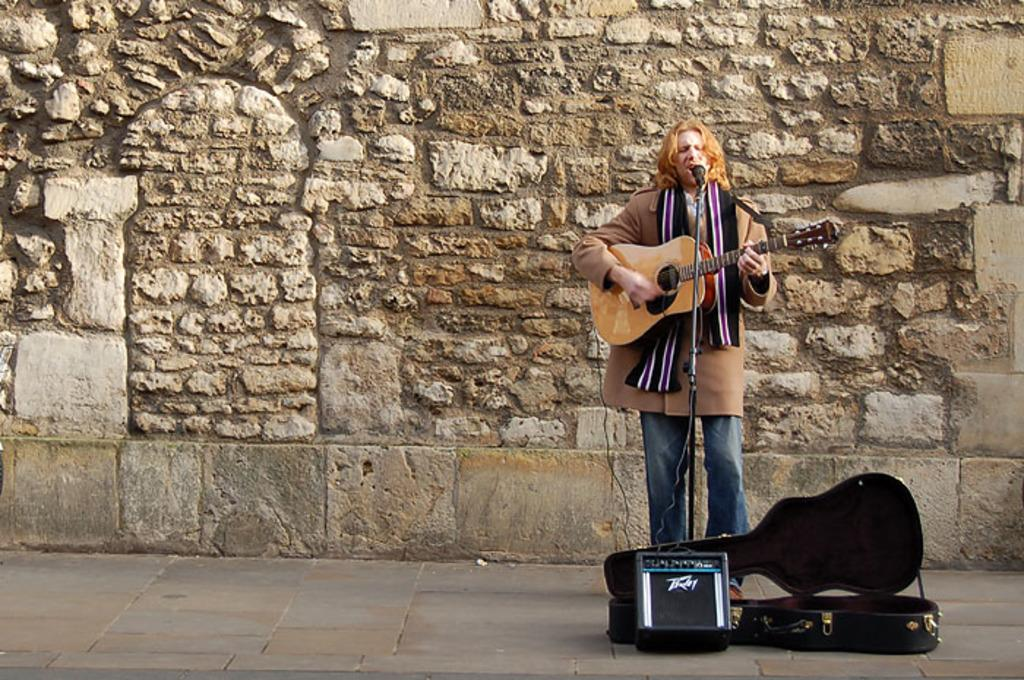What is the main subject of the image? The main subject of the image is a man. What is the man doing in the image? The man is singing and playing the guitar in the image. What is the man standing on? The man is standing on the floor in the image. What can be seen in the background of the image? There is a wall in the background of the image. What type of pan is hanging on the wall in the image? There is no pan present in the image; the wall is the only element mentioned in the background. 